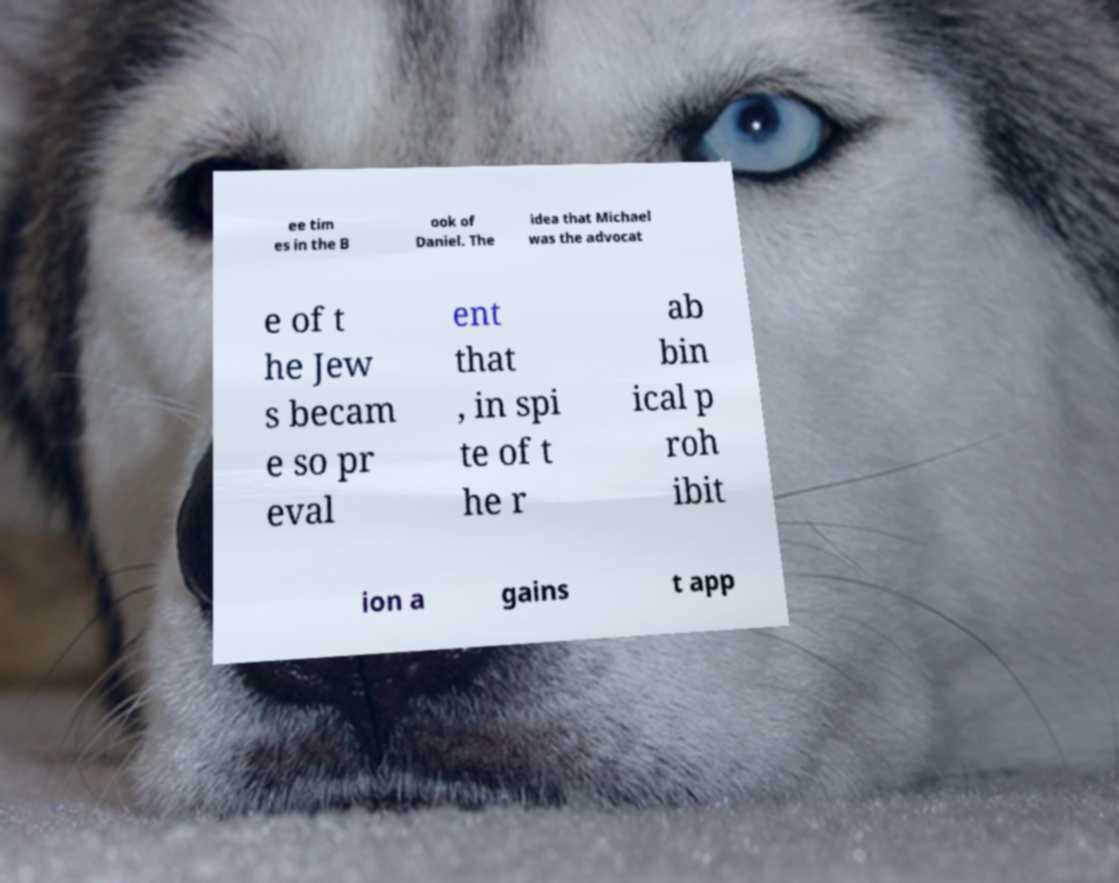I need the written content from this picture converted into text. Can you do that? ee tim es in the B ook of Daniel. The idea that Michael was the advocat e of t he Jew s becam e so pr eval ent that , in spi te of t he r ab bin ical p roh ibit ion a gains t app 